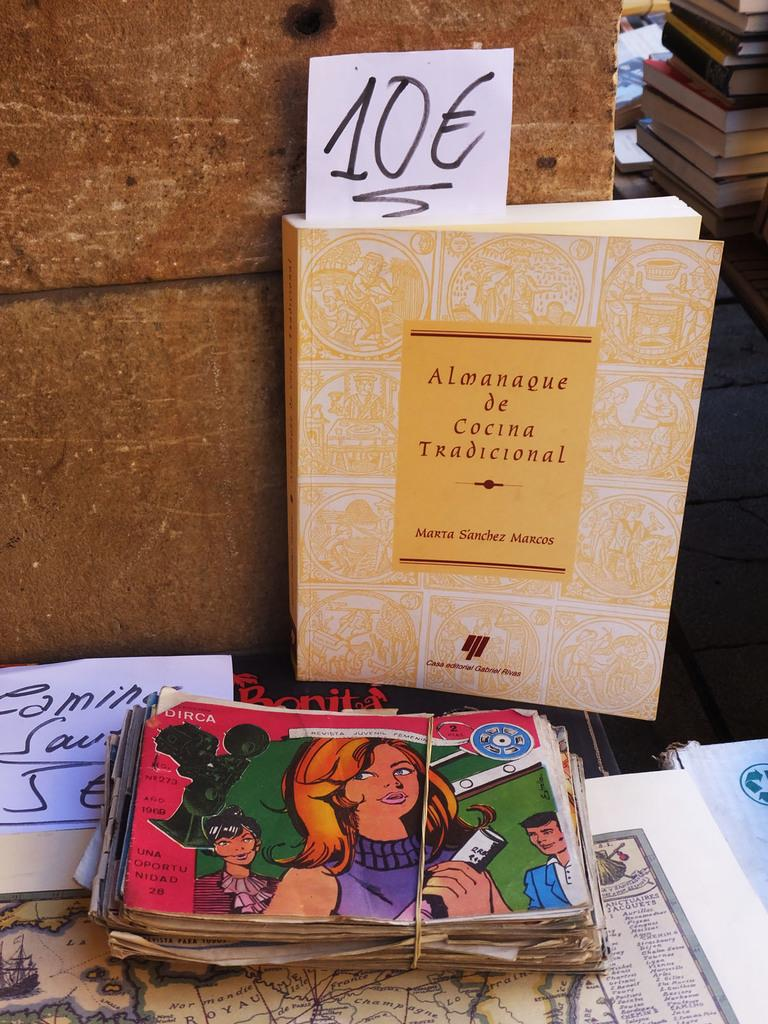<image>
Write a terse but informative summary of the picture. A book stands tall with the title Almanaque de Cocina Tradicional in the background of a sale 